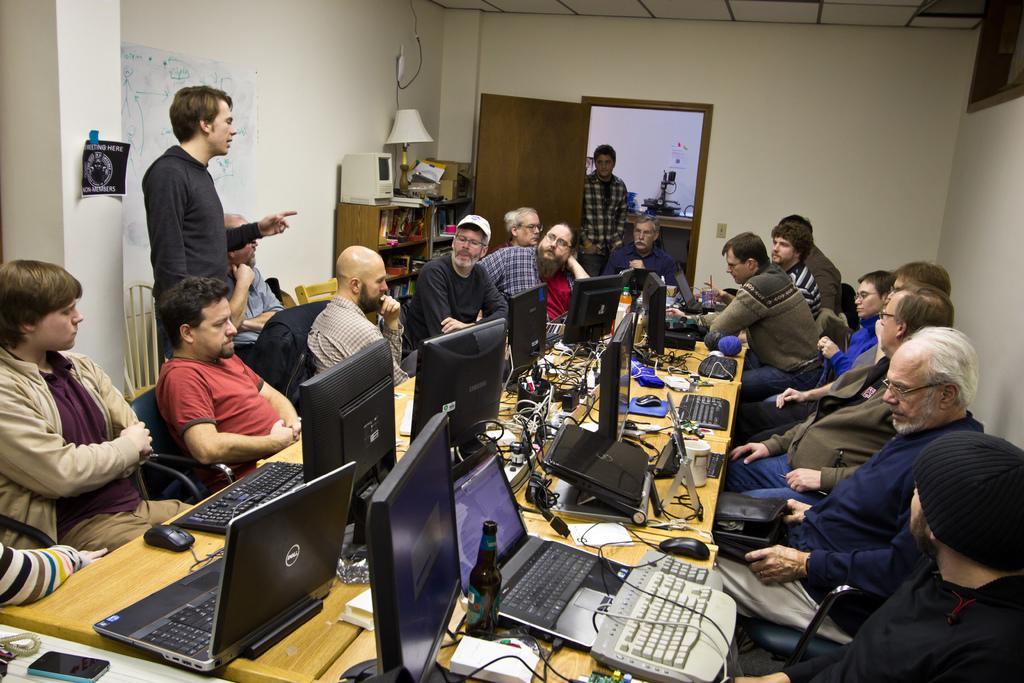Describe this image in one or two sentences. The image is taken inside a room. In the foreground of the picture there is a table, on the table there are laptops, desktops, cables, plug boards, mouses and various objects. On the right there are people, chair and wall. On the left there are people, chairs and wall. In the middle of the picture there is a door, near the door there is a person standing. Towards left we can a desk, on the desk there are lamp, books and various other objects. At the top it is ceiling. Outside the door we can see wall, flower vase and desk. 